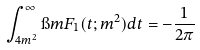Convert formula to latex. <formula><loc_0><loc_0><loc_500><loc_500>\int _ { 4 m ^ { 2 } } ^ { \infty } \i m F _ { 1 } ( t ; m ^ { 2 } ) d t = - \frac { 1 } { 2 \pi }</formula> 